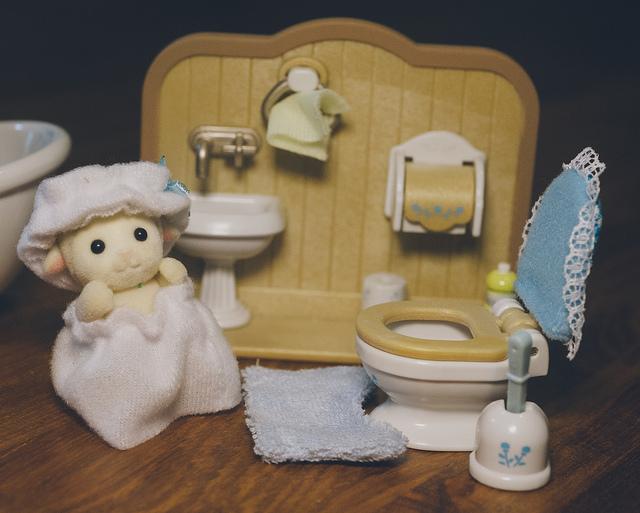What is the lamb toy wearing?
Write a very short answer. Towel. What type of animal is this?
Quick response, please. Lamb. Where would this figurine be appropriate?
Short answer required. Bathroom. What room would this be called?
Short answer required. Bathroom. What is smiling in the picture?
Answer briefly. Doll. Is the image in black and white?
Write a very short answer. No. Is this animal real?
Write a very short answer. No. How was the bear's blanket constructed?
Give a very brief answer. Sewn. What color is the surface the objects are on?
Write a very short answer. Brown. Are these expensive?
Short answer required. No. What color is the towels?
Keep it brief. White. Does this bathroom have a lot of detail?
Concise answer only. Yes. What color are these creatures?
Write a very short answer. White. How many stuffed animals are shown?
Write a very short answer. 1. 